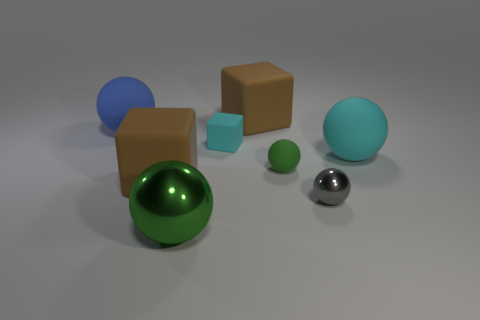Are there any other small balls that have the same color as the tiny metallic sphere?
Your response must be concise. No. The matte sphere that is the same size as the blue matte object is what color?
Your answer should be very brief. Cyan. Do the tiny rubber ball and the big block behind the blue ball have the same color?
Your answer should be compact. No. What color is the tiny metal thing?
Offer a very short reply. Gray. What is the material of the big brown thing in front of the large blue matte ball?
Offer a very short reply. Rubber. There is a cyan thing that is the same shape as the green metal object; what is its size?
Provide a short and direct response. Large. Are there fewer cyan balls that are behind the blue sphere than small spheres?
Offer a terse response. Yes. Are any green shiny things visible?
Offer a terse response. Yes. There is another large rubber thing that is the same shape as the large cyan thing; what is its color?
Provide a succinct answer. Blue. Do the shiny object that is behind the large green shiny sphere and the small cube have the same color?
Provide a short and direct response. No. 